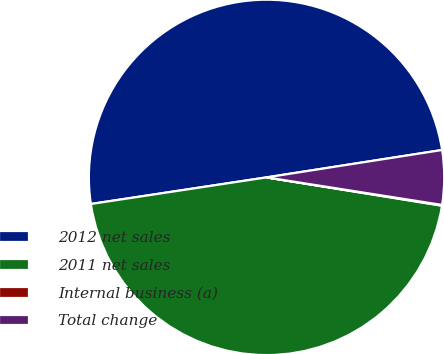Convert chart to OTSL. <chart><loc_0><loc_0><loc_500><loc_500><pie_chart><fcel>2012 net sales<fcel>2011 net sales<fcel>Internal business (a)<fcel>Total change<nl><fcel>49.93%<fcel>45.06%<fcel>0.07%<fcel>4.94%<nl></chart> 